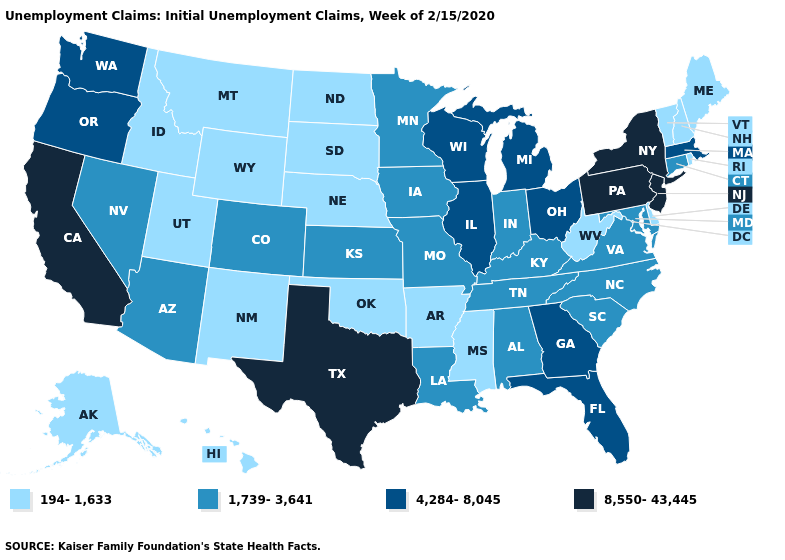What is the value of Wyoming?
Write a very short answer. 194-1,633. Name the states that have a value in the range 8,550-43,445?
Concise answer only. California, New Jersey, New York, Pennsylvania, Texas. Does the first symbol in the legend represent the smallest category?
Be succinct. Yes. Does New York have a higher value than South Carolina?
Write a very short answer. Yes. What is the value of Montana?
Give a very brief answer. 194-1,633. Name the states that have a value in the range 4,284-8,045?
Keep it brief. Florida, Georgia, Illinois, Massachusetts, Michigan, Ohio, Oregon, Washington, Wisconsin. Does Idaho have a lower value than Vermont?
Short answer required. No. What is the value of Rhode Island?
Answer briefly. 194-1,633. Name the states that have a value in the range 4,284-8,045?
Write a very short answer. Florida, Georgia, Illinois, Massachusetts, Michigan, Ohio, Oregon, Washington, Wisconsin. Which states have the lowest value in the Northeast?
Answer briefly. Maine, New Hampshire, Rhode Island, Vermont. Name the states that have a value in the range 4,284-8,045?
Answer briefly. Florida, Georgia, Illinois, Massachusetts, Michigan, Ohio, Oregon, Washington, Wisconsin. Which states have the highest value in the USA?
Quick response, please. California, New Jersey, New York, Pennsylvania, Texas. Does Idaho have the lowest value in the USA?
Write a very short answer. Yes. Name the states that have a value in the range 194-1,633?
Write a very short answer. Alaska, Arkansas, Delaware, Hawaii, Idaho, Maine, Mississippi, Montana, Nebraska, New Hampshire, New Mexico, North Dakota, Oklahoma, Rhode Island, South Dakota, Utah, Vermont, West Virginia, Wyoming. 